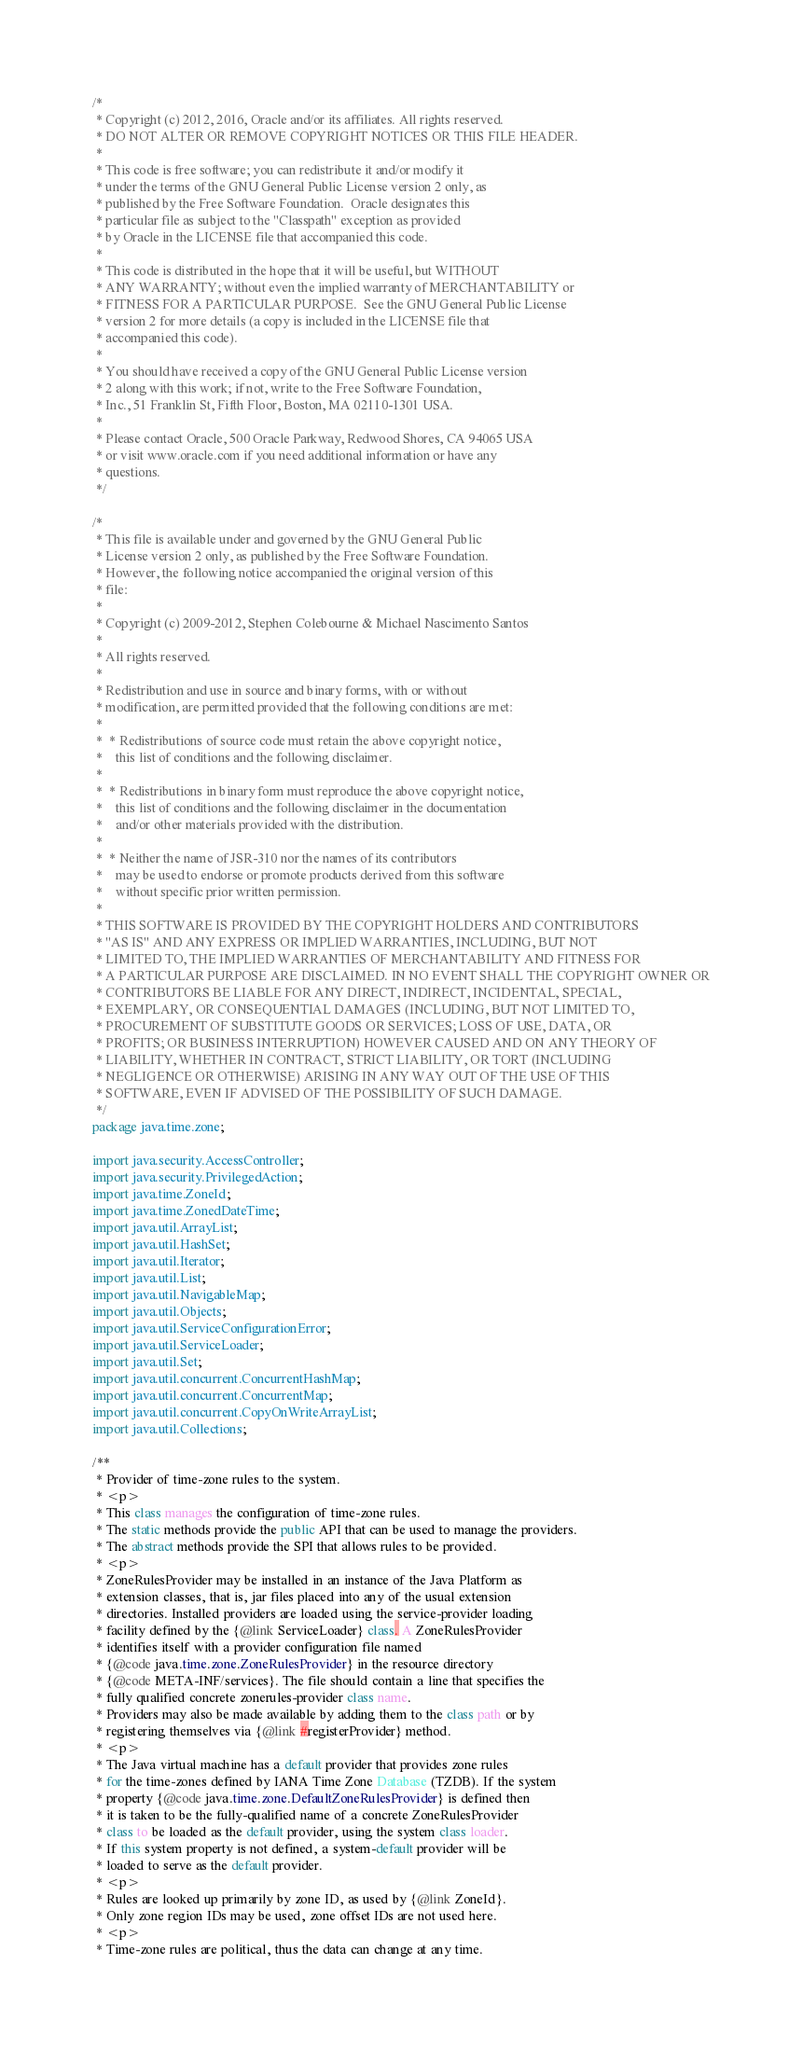<code> <loc_0><loc_0><loc_500><loc_500><_Java_>/*
 * Copyright (c) 2012, 2016, Oracle and/or its affiliates. All rights reserved.
 * DO NOT ALTER OR REMOVE COPYRIGHT NOTICES OR THIS FILE HEADER.
 *
 * This code is free software; you can redistribute it and/or modify it
 * under the terms of the GNU General Public License version 2 only, as
 * published by the Free Software Foundation.  Oracle designates this
 * particular file as subject to the "Classpath" exception as provided
 * by Oracle in the LICENSE file that accompanied this code.
 *
 * This code is distributed in the hope that it will be useful, but WITHOUT
 * ANY WARRANTY; without even the implied warranty of MERCHANTABILITY or
 * FITNESS FOR A PARTICULAR PURPOSE.  See the GNU General Public License
 * version 2 for more details (a copy is included in the LICENSE file that
 * accompanied this code).
 *
 * You should have received a copy of the GNU General Public License version
 * 2 along with this work; if not, write to the Free Software Foundation,
 * Inc., 51 Franklin St, Fifth Floor, Boston, MA 02110-1301 USA.
 *
 * Please contact Oracle, 500 Oracle Parkway, Redwood Shores, CA 94065 USA
 * or visit www.oracle.com if you need additional information or have any
 * questions.
 */

/*
 * This file is available under and governed by the GNU General Public
 * License version 2 only, as published by the Free Software Foundation.
 * However, the following notice accompanied the original version of this
 * file:
 *
 * Copyright (c) 2009-2012, Stephen Colebourne & Michael Nascimento Santos
 *
 * All rights reserved.
 *
 * Redistribution and use in source and binary forms, with or without
 * modification, are permitted provided that the following conditions are met:
 *
 *  * Redistributions of source code must retain the above copyright notice,
 *    this list of conditions and the following disclaimer.
 *
 *  * Redistributions in binary form must reproduce the above copyright notice,
 *    this list of conditions and the following disclaimer in the documentation
 *    and/or other materials provided with the distribution.
 *
 *  * Neither the name of JSR-310 nor the names of its contributors
 *    may be used to endorse or promote products derived from this software
 *    without specific prior written permission.
 *
 * THIS SOFTWARE IS PROVIDED BY THE COPYRIGHT HOLDERS AND CONTRIBUTORS
 * "AS IS" AND ANY EXPRESS OR IMPLIED WARRANTIES, INCLUDING, BUT NOT
 * LIMITED TO, THE IMPLIED WARRANTIES OF MERCHANTABILITY AND FITNESS FOR
 * A PARTICULAR PURPOSE ARE DISCLAIMED. IN NO EVENT SHALL THE COPYRIGHT OWNER OR
 * CONTRIBUTORS BE LIABLE FOR ANY DIRECT, INDIRECT, INCIDENTAL, SPECIAL,
 * EXEMPLARY, OR CONSEQUENTIAL DAMAGES (INCLUDING, BUT NOT LIMITED TO,
 * PROCUREMENT OF SUBSTITUTE GOODS OR SERVICES; LOSS OF USE, DATA, OR
 * PROFITS; OR BUSINESS INTERRUPTION) HOWEVER CAUSED AND ON ANY THEORY OF
 * LIABILITY, WHETHER IN CONTRACT, STRICT LIABILITY, OR TORT (INCLUDING
 * NEGLIGENCE OR OTHERWISE) ARISING IN ANY WAY OUT OF THE USE OF THIS
 * SOFTWARE, EVEN IF ADVISED OF THE POSSIBILITY OF SUCH DAMAGE.
 */
package java.time.zone;

import java.security.AccessController;
import java.security.PrivilegedAction;
import java.time.ZoneId;
import java.time.ZonedDateTime;
import java.util.ArrayList;
import java.util.HashSet;
import java.util.Iterator;
import java.util.List;
import java.util.NavigableMap;
import java.util.Objects;
import java.util.ServiceConfigurationError;
import java.util.ServiceLoader;
import java.util.Set;
import java.util.concurrent.ConcurrentHashMap;
import java.util.concurrent.ConcurrentMap;
import java.util.concurrent.CopyOnWriteArrayList;
import java.util.Collections;

/**
 * Provider of time-zone rules to the system.
 * <p>
 * This class manages the configuration of time-zone rules.
 * The static methods provide the public API that can be used to manage the providers.
 * The abstract methods provide the SPI that allows rules to be provided.
 * <p>
 * ZoneRulesProvider may be installed in an instance of the Java Platform as
 * extension classes, that is, jar files placed into any of the usual extension
 * directories. Installed providers are loaded using the service-provider loading
 * facility defined by the {@link ServiceLoader} class. A ZoneRulesProvider
 * identifies itself with a provider configuration file named
 * {@code java.time.zone.ZoneRulesProvider} in the resource directory
 * {@code META-INF/services}. The file should contain a line that specifies the
 * fully qualified concrete zonerules-provider class name.
 * Providers may also be made available by adding them to the class path or by
 * registering themselves via {@link #registerProvider} method.
 * <p>
 * The Java virtual machine has a default provider that provides zone rules
 * for the time-zones defined by IANA Time Zone Database (TZDB). If the system
 * property {@code java.time.zone.DefaultZoneRulesProvider} is defined then
 * it is taken to be the fully-qualified name of a concrete ZoneRulesProvider
 * class to be loaded as the default provider, using the system class loader.
 * If this system property is not defined, a system-default provider will be
 * loaded to serve as the default provider.
 * <p>
 * Rules are looked up primarily by zone ID, as used by {@link ZoneId}.
 * Only zone region IDs may be used, zone offset IDs are not used here.
 * <p>
 * Time-zone rules are political, thus the data can change at any time.</code> 